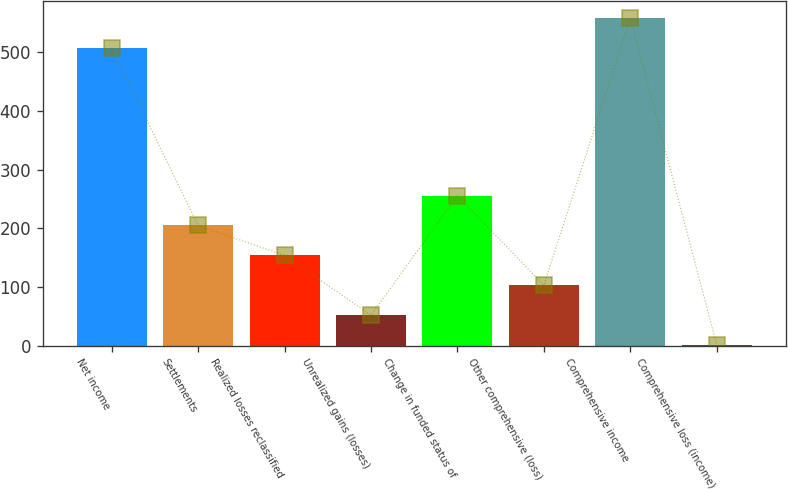Convert chart to OTSL. <chart><loc_0><loc_0><loc_500><loc_500><bar_chart><fcel>Net income<fcel>Settlements<fcel>Realized losses reclassified<fcel>Unrealized gains (losses)<fcel>Change in funded status of<fcel>Other comprehensive (loss)<fcel>Comprehensive income<fcel>Comprehensive loss (income)<nl><fcel>507.5<fcel>204.76<fcel>153.82<fcel>51.94<fcel>255.7<fcel>102.88<fcel>558.44<fcel>1<nl></chart> 